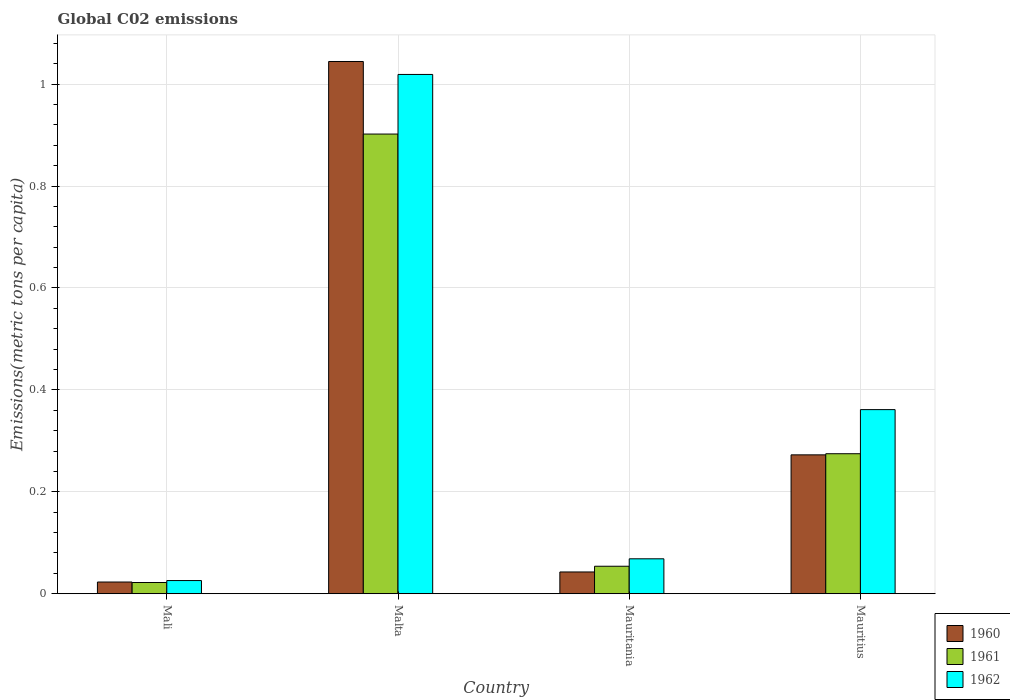How many different coloured bars are there?
Give a very brief answer. 3. How many bars are there on the 3rd tick from the left?
Provide a succinct answer. 3. How many bars are there on the 3rd tick from the right?
Your response must be concise. 3. What is the label of the 4th group of bars from the left?
Provide a succinct answer. Mauritius. In how many cases, is the number of bars for a given country not equal to the number of legend labels?
Provide a succinct answer. 0. What is the amount of CO2 emitted in in 1960 in Mauritania?
Offer a terse response. 0.04. Across all countries, what is the maximum amount of CO2 emitted in in 1962?
Make the answer very short. 1.02. Across all countries, what is the minimum amount of CO2 emitted in in 1962?
Provide a succinct answer. 0.03. In which country was the amount of CO2 emitted in in 1960 maximum?
Offer a terse response. Malta. In which country was the amount of CO2 emitted in in 1960 minimum?
Your response must be concise. Mali. What is the total amount of CO2 emitted in in 1960 in the graph?
Offer a terse response. 1.38. What is the difference between the amount of CO2 emitted in in 1960 in Malta and that in Mauritania?
Offer a very short reply. 1. What is the difference between the amount of CO2 emitted in in 1960 in Mauritius and the amount of CO2 emitted in in 1962 in Mali?
Offer a terse response. 0.25. What is the average amount of CO2 emitted in in 1961 per country?
Ensure brevity in your answer.  0.31. What is the difference between the amount of CO2 emitted in of/in 1961 and amount of CO2 emitted in of/in 1960 in Malta?
Your answer should be very brief. -0.14. In how many countries, is the amount of CO2 emitted in in 1961 greater than 0.12 metric tons per capita?
Offer a terse response. 2. What is the ratio of the amount of CO2 emitted in in 1962 in Malta to that in Mauritius?
Your answer should be very brief. 2.82. Is the difference between the amount of CO2 emitted in in 1961 in Mali and Mauritania greater than the difference between the amount of CO2 emitted in in 1960 in Mali and Mauritania?
Your answer should be very brief. No. What is the difference between the highest and the second highest amount of CO2 emitted in in 1961?
Offer a very short reply. 0.63. What is the difference between the highest and the lowest amount of CO2 emitted in in 1961?
Your answer should be compact. 0.88. What does the 1st bar from the left in Malta represents?
Ensure brevity in your answer.  1960. What does the 1st bar from the right in Mauritius represents?
Give a very brief answer. 1962. How many bars are there?
Your answer should be compact. 12. How many countries are there in the graph?
Make the answer very short. 4. Are the values on the major ticks of Y-axis written in scientific E-notation?
Your answer should be very brief. No. How many legend labels are there?
Your answer should be very brief. 3. What is the title of the graph?
Offer a terse response. Global C02 emissions. What is the label or title of the X-axis?
Provide a short and direct response. Country. What is the label or title of the Y-axis?
Your answer should be compact. Emissions(metric tons per capita). What is the Emissions(metric tons per capita) in 1960 in Mali?
Offer a very short reply. 0.02. What is the Emissions(metric tons per capita) of 1961 in Mali?
Your answer should be compact. 0.02. What is the Emissions(metric tons per capita) of 1962 in Mali?
Make the answer very short. 0.03. What is the Emissions(metric tons per capita) in 1960 in Malta?
Provide a short and direct response. 1.04. What is the Emissions(metric tons per capita) in 1961 in Malta?
Make the answer very short. 0.9. What is the Emissions(metric tons per capita) of 1962 in Malta?
Your answer should be compact. 1.02. What is the Emissions(metric tons per capita) in 1960 in Mauritania?
Offer a very short reply. 0.04. What is the Emissions(metric tons per capita) of 1961 in Mauritania?
Offer a very short reply. 0.05. What is the Emissions(metric tons per capita) in 1962 in Mauritania?
Offer a very short reply. 0.07. What is the Emissions(metric tons per capita) of 1960 in Mauritius?
Offer a very short reply. 0.27. What is the Emissions(metric tons per capita) in 1961 in Mauritius?
Offer a terse response. 0.27. What is the Emissions(metric tons per capita) of 1962 in Mauritius?
Offer a very short reply. 0.36. Across all countries, what is the maximum Emissions(metric tons per capita) of 1960?
Provide a short and direct response. 1.04. Across all countries, what is the maximum Emissions(metric tons per capita) in 1961?
Offer a terse response. 0.9. Across all countries, what is the maximum Emissions(metric tons per capita) of 1962?
Offer a very short reply. 1.02. Across all countries, what is the minimum Emissions(metric tons per capita) in 1960?
Your answer should be very brief. 0.02. Across all countries, what is the minimum Emissions(metric tons per capita) in 1961?
Your response must be concise. 0.02. Across all countries, what is the minimum Emissions(metric tons per capita) of 1962?
Keep it short and to the point. 0.03. What is the total Emissions(metric tons per capita) of 1960 in the graph?
Your response must be concise. 1.38. What is the total Emissions(metric tons per capita) of 1961 in the graph?
Offer a very short reply. 1.25. What is the total Emissions(metric tons per capita) of 1962 in the graph?
Give a very brief answer. 1.47. What is the difference between the Emissions(metric tons per capita) of 1960 in Mali and that in Malta?
Provide a short and direct response. -1.02. What is the difference between the Emissions(metric tons per capita) of 1961 in Mali and that in Malta?
Provide a short and direct response. -0.88. What is the difference between the Emissions(metric tons per capita) in 1962 in Mali and that in Malta?
Ensure brevity in your answer.  -0.99. What is the difference between the Emissions(metric tons per capita) of 1960 in Mali and that in Mauritania?
Ensure brevity in your answer.  -0.02. What is the difference between the Emissions(metric tons per capita) of 1961 in Mali and that in Mauritania?
Keep it short and to the point. -0.03. What is the difference between the Emissions(metric tons per capita) of 1962 in Mali and that in Mauritania?
Your response must be concise. -0.04. What is the difference between the Emissions(metric tons per capita) in 1960 in Mali and that in Mauritius?
Offer a terse response. -0.25. What is the difference between the Emissions(metric tons per capita) of 1961 in Mali and that in Mauritius?
Make the answer very short. -0.25. What is the difference between the Emissions(metric tons per capita) in 1962 in Mali and that in Mauritius?
Provide a short and direct response. -0.34. What is the difference between the Emissions(metric tons per capita) of 1960 in Malta and that in Mauritania?
Give a very brief answer. 1. What is the difference between the Emissions(metric tons per capita) of 1961 in Malta and that in Mauritania?
Offer a very short reply. 0.85. What is the difference between the Emissions(metric tons per capita) of 1962 in Malta and that in Mauritania?
Your response must be concise. 0.95. What is the difference between the Emissions(metric tons per capita) of 1960 in Malta and that in Mauritius?
Provide a succinct answer. 0.77. What is the difference between the Emissions(metric tons per capita) of 1961 in Malta and that in Mauritius?
Give a very brief answer. 0.63. What is the difference between the Emissions(metric tons per capita) of 1962 in Malta and that in Mauritius?
Your response must be concise. 0.66. What is the difference between the Emissions(metric tons per capita) in 1960 in Mauritania and that in Mauritius?
Provide a succinct answer. -0.23. What is the difference between the Emissions(metric tons per capita) of 1961 in Mauritania and that in Mauritius?
Your response must be concise. -0.22. What is the difference between the Emissions(metric tons per capita) in 1962 in Mauritania and that in Mauritius?
Keep it short and to the point. -0.29. What is the difference between the Emissions(metric tons per capita) of 1960 in Mali and the Emissions(metric tons per capita) of 1961 in Malta?
Provide a short and direct response. -0.88. What is the difference between the Emissions(metric tons per capita) of 1960 in Mali and the Emissions(metric tons per capita) of 1962 in Malta?
Give a very brief answer. -1. What is the difference between the Emissions(metric tons per capita) in 1961 in Mali and the Emissions(metric tons per capita) in 1962 in Malta?
Give a very brief answer. -1. What is the difference between the Emissions(metric tons per capita) in 1960 in Mali and the Emissions(metric tons per capita) in 1961 in Mauritania?
Offer a terse response. -0.03. What is the difference between the Emissions(metric tons per capita) in 1960 in Mali and the Emissions(metric tons per capita) in 1962 in Mauritania?
Offer a very short reply. -0.05. What is the difference between the Emissions(metric tons per capita) in 1961 in Mali and the Emissions(metric tons per capita) in 1962 in Mauritania?
Ensure brevity in your answer.  -0.05. What is the difference between the Emissions(metric tons per capita) in 1960 in Mali and the Emissions(metric tons per capita) in 1961 in Mauritius?
Provide a succinct answer. -0.25. What is the difference between the Emissions(metric tons per capita) of 1960 in Mali and the Emissions(metric tons per capita) of 1962 in Mauritius?
Your answer should be very brief. -0.34. What is the difference between the Emissions(metric tons per capita) in 1961 in Mali and the Emissions(metric tons per capita) in 1962 in Mauritius?
Ensure brevity in your answer.  -0.34. What is the difference between the Emissions(metric tons per capita) in 1960 in Malta and the Emissions(metric tons per capita) in 1961 in Mauritania?
Make the answer very short. 0.99. What is the difference between the Emissions(metric tons per capita) of 1960 in Malta and the Emissions(metric tons per capita) of 1962 in Mauritania?
Your answer should be compact. 0.98. What is the difference between the Emissions(metric tons per capita) of 1961 in Malta and the Emissions(metric tons per capita) of 1962 in Mauritania?
Offer a terse response. 0.83. What is the difference between the Emissions(metric tons per capita) in 1960 in Malta and the Emissions(metric tons per capita) in 1961 in Mauritius?
Your answer should be compact. 0.77. What is the difference between the Emissions(metric tons per capita) of 1960 in Malta and the Emissions(metric tons per capita) of 1962 in Mauritius?
Keep it short and to the point. 0.68. What is the difference between the Emissions(metric tons per capita) of 1961 in Malta and the Emissions(metric tons per capita) of 1962 in Mauritius?
Provide a short and direct response. 0.54. What is the difference between the Emissions(metric tons per capita) in 1960 in Mauritania and the Emissions(metric tons per capita) in 1961 in Mauritius?
Offer a terse response. -0.23. What is the difference between the Emissions(metric tons per capita) of 1960 in Mauritania and the Emissions(metric tons per capita) of 1962 in Mauritius?
Give a very brief answer. -0.32. What is the difference between the Emissions(metric tons per capita) of 1961 in Mauritania and the Emissions(metric tons per capita) of 1962 in Mauritius?
Make the answer very short. -0.31. What is the average Emissions(metric tons per capita) in 1960 per country?
Keep it short and to the point. 0.35. What is the average Emissions(metric tons per capita) of 1961 per country?
Your answer should be compact. 0.31. What is the average Emissions(metric tons per capita) of 1962 per country?
Provide a succinct answer. 0.37. What is the difference between the Emissions(metric tons per capita) of 1960 and Emissions(metric tons per capita) of 1961 in Mali?
Make the answer very short. 0. What is the difference between the Emissions(metric tons per capita) of 1960 and Emissions(metric tons per capita) of 1962 in Mali?
Provide a short and direct response. -0. What is the difference between the Emissions(metric tons per capita) of 1961 and Emissions(metric tons per capita) of 1962 in Mali?
Offer a terse response. -0. What is the difference between the Emissions(metric tons per capita) in 1960 and Emissions(metric tons per capita) in 1961 in Malta?
Keep it short and to the point. 0.14. What is the difference between the Emissions(metric tons per capita) of 1960 and Emissions(metric tons per capita) of 1962 in Malta?
Keep it short and to the point. 0.03. What is the difference between the Emissions(metric tons per capita) in 1961 and Emissions(metric tons per capita) in 1962 in Malta?
Offer a very short reply. -0.12. What is the difference between the Emissions(metric tons per capita) in 1960 and Emissions(metric tons per capita) in 1961 in Mauritania?
Offer a very short reply. -0.01. What is the difference between the Emissions(metric tons per capita) in 1960 and Emissions(metric tons per capita) in 1962 in Mauritania?
Provide a succinct answer. -0.03. What is the difference between the Emissions(metric tons per capita) of 1961 and Emissions(metric tons per capita) of 1962 in Mauritania?
Provide a succinct answer. -0.01. What is the difference between the Emissions(metric tons per capita) of 1960 and Emissions(metric tons per capita) of 1961 in Mauritius?
Ensure brevity in your answer.  -0. What is the difference between the Emissions(metric tons per capita) in 1960 and Emissions(metric tons per capita) in 1962 in Mauritius?
Make the answer very short. -0.09. What is the difference between the Emissions(metric tons per capita) of 1961 and Emissions(metric tons per capita) of 1962 in Mauritius?
Give a very brief answer. -0.09. What is the ratio of the Emissions(metric tons per capita) of 1960 in Mali to that in Malta?
Give a very brief answer. 0.02. What is the ratio of the Emissions(metric tons per capita) in 1961 in Mali to that in Malta?
Keep it short and to the point. 0.02. What is the ratio of the Emissions(metric tons per capita) of 1962 in Mali to that in Malta?
Your answer should be very brief. 0.03. What is the ratio of the Emissions(metric tons per capita) of 1960 in Mali to that in Mauritania?
Your response must be concise. 0.54. What is the ratio of the Emissions(metric tons per capita) in 1961 in Mali to that in Mauritania?
Make the answer very short. 0.41. What is the ratio of the Emissions(metric tons per capita) of 1962 in Mali to that in Mauritania?
Your response must be concise. 0.38. What is the ratio of the Emissions(metric tons per capita) of 1960 in Mali to that in Mauritius?
Your response must be concise. 0.08. What is the ratio of the Emissions(metric tons per capita) in 1961 in Mali to that in Mauritius?
Your response must be concise. 0.08. What is the ratio of the Emissions(metric tons per capita) of 1962 in Mali to that in Mauritius?
Your response must be concise. 0.07. What is the ratio of the Emissions(metric tons per capita) of 1960 in Malta to that in Mauritania?
Provide a succinct answer. 24.44. What is the ratio of the Emissions(metric tons per capita) of 1961 in Malta to that in Mauritania?
Offer a terse response. 16.71. What is the ratio of the Emissions(metric tons per capita) in 1962 in Malta to that in Mauritania?
Your response must be concise. 14.86. What is the ratio of the Emissions(metric tons per capita) of 1960 in Malta to that in Mauritius?
Your response must be concise. 3.83. What is the ratio of the Emissions(metric tons per capita) of 1961 in Malta to that in Mauritius?
Provide a short and direct response. 3.28. What is the ratio of the Emissions(metric tons per capita) of 1962 in Malta to that in Mauritius?
Keep it short and to the point. 2.82. What is the ratio of the Emissions(metric tons per capita) of 1960 in Mauritania to that in Mauritius?
Provide a short and direct response. 0.16. What is the ratio of the Emissions(metric tons per capita) of 1961 in Mauritania to that in Mauritius?
Your answer should be compact. 0.2. What is the ratio of the Emissions(metric tons per capita) of 1962 in Mauritania to that in Mauritius?
Offer a very short reply. 0.19. What is the difference between the highest and the second highest Emissions(metric tons per capita) in 1960?
Your answer should be very brief. 0.77. What is the difference between the highest and the second highest Emissions(metric tons per capita) of 1961?
Offer a terse response. 0.63. What is the difference between the highest and the second highest Emissions(metric tons per capita) in 1962?
Provide a short and direct response. 0.66. What is the difference between the highest and the lowest Emissions(metric tons per capita) of 1960?
Provide a succinct answer. 1.02. What is the difference between the highest and the lowest Emissions(metric tons per capita) of 1961?
Your response must be concise. 0.88. What is the difference between the highest and the lowest Emissions(metric tons per capita) of 1962?
Your answer should be compact. 0.99. 